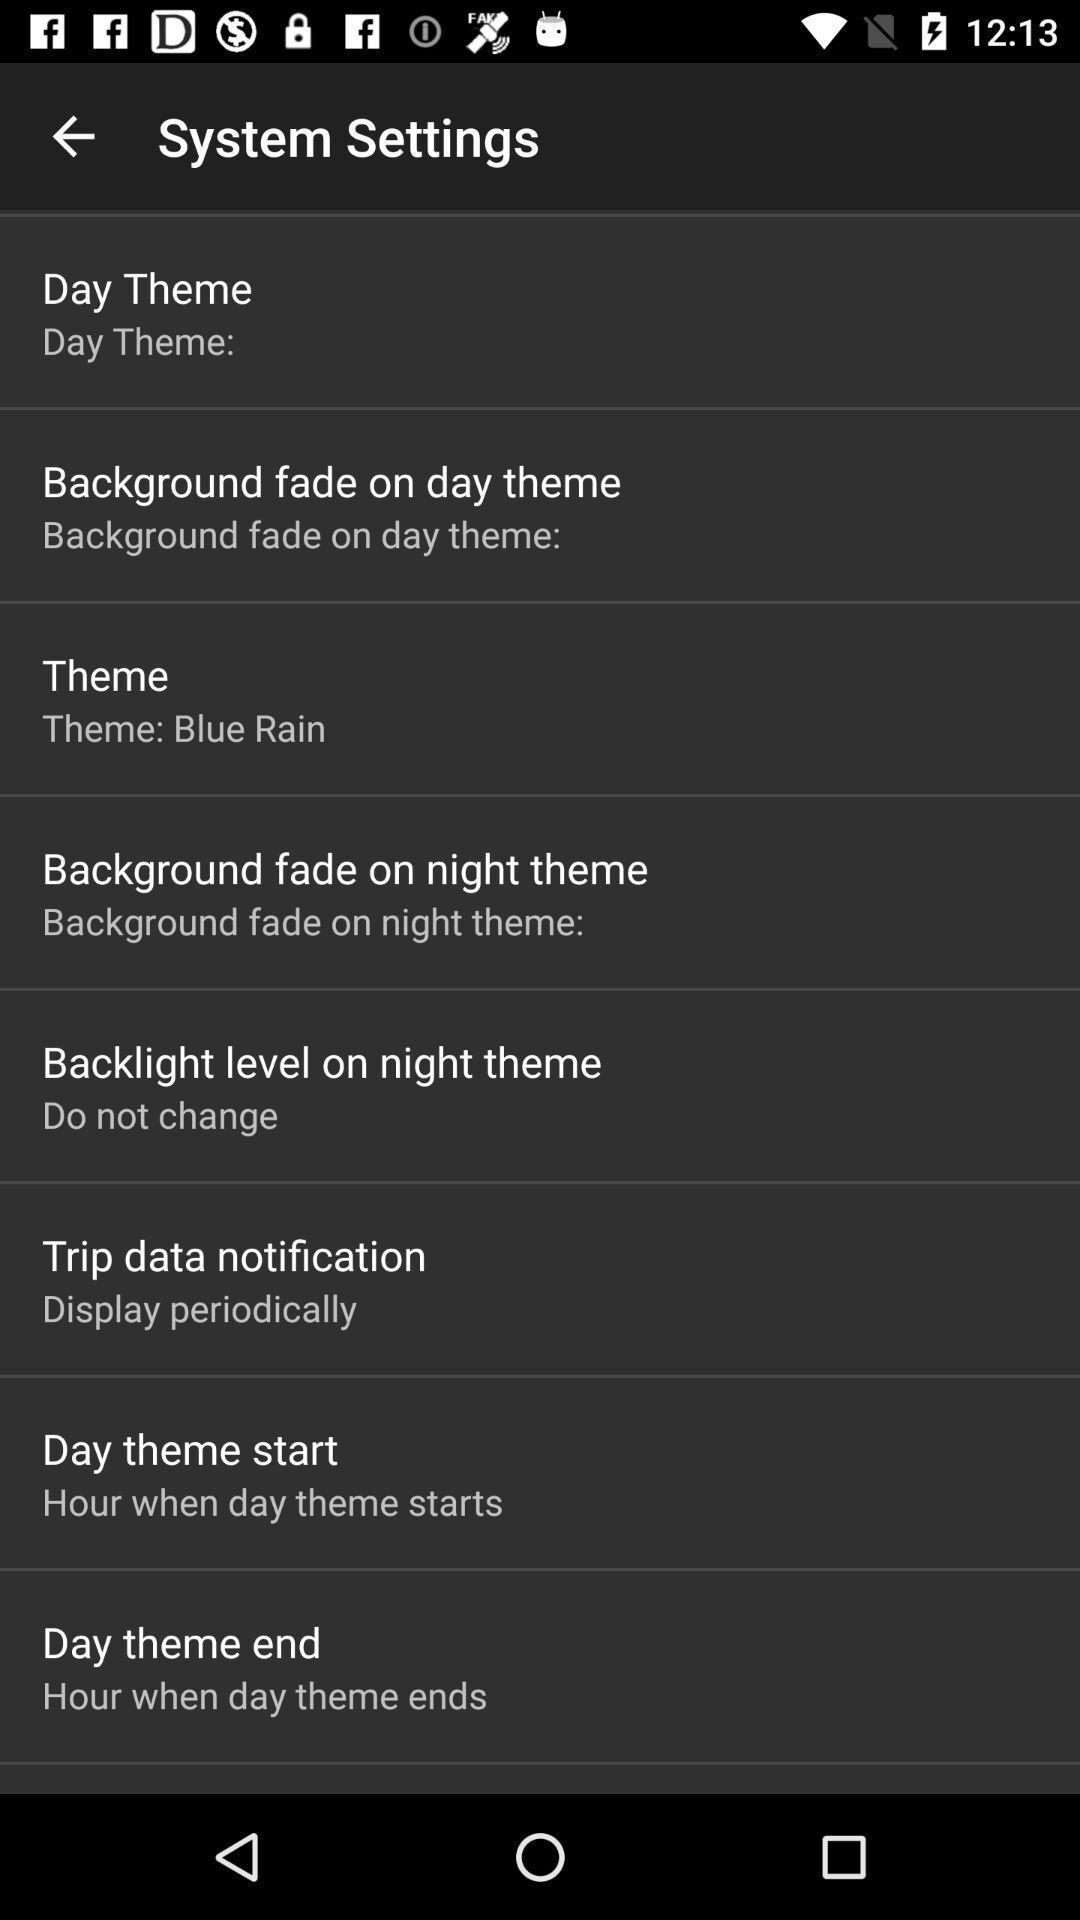Provide a description of this screenshot. System settings page of a theming app. 